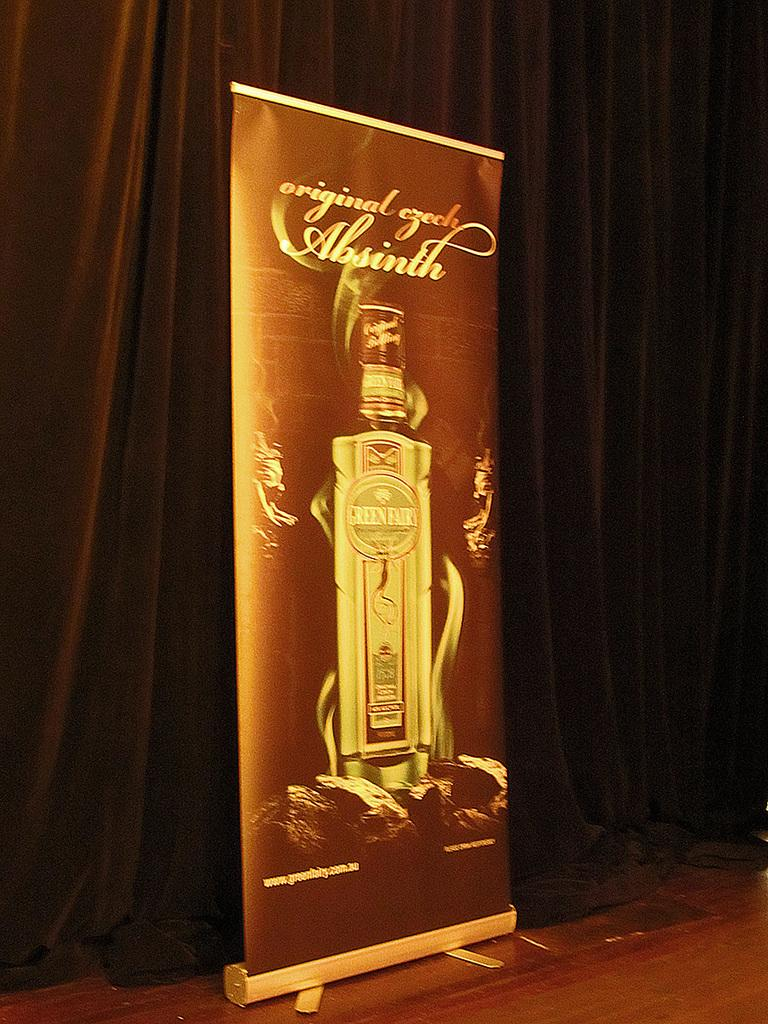<image>
Render a clear and concise summary of the photo. a sign with Absinth written on the front 